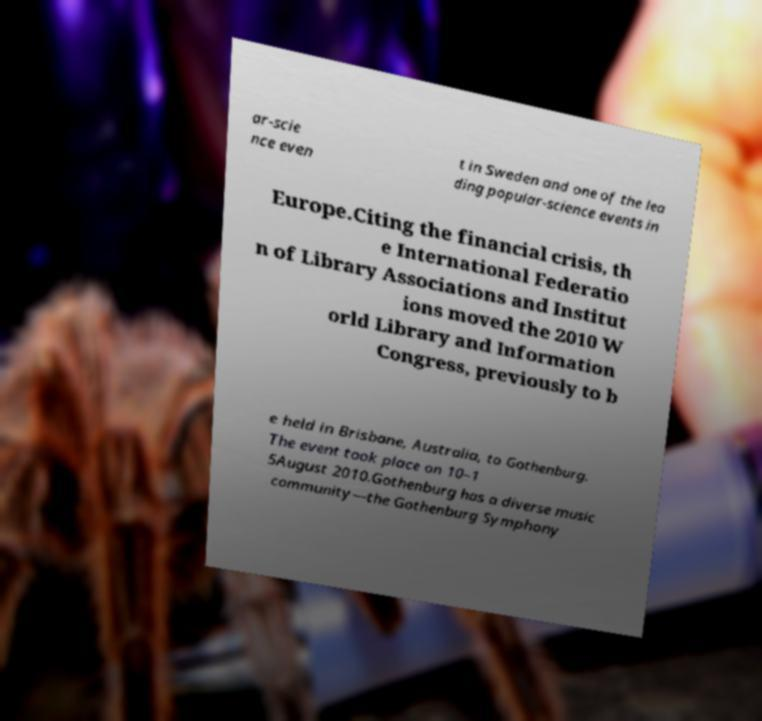For documentation purposes, I need the text within this image transcribed. Could you provide that? ar-scie nce even t in Sweden and one of the lea ding popular-science events in Europe.Citing the financial crisis, th e International Federatio n of Library Associations and Institut ions moved the 2010 W orld Library and Information Congress, previously to b e held in Brisbane, Australia, to Gothenburg. The event took place on 10–1 5August 2010.Gothenburg has a diverse music community—the Gothenburg Symphony 